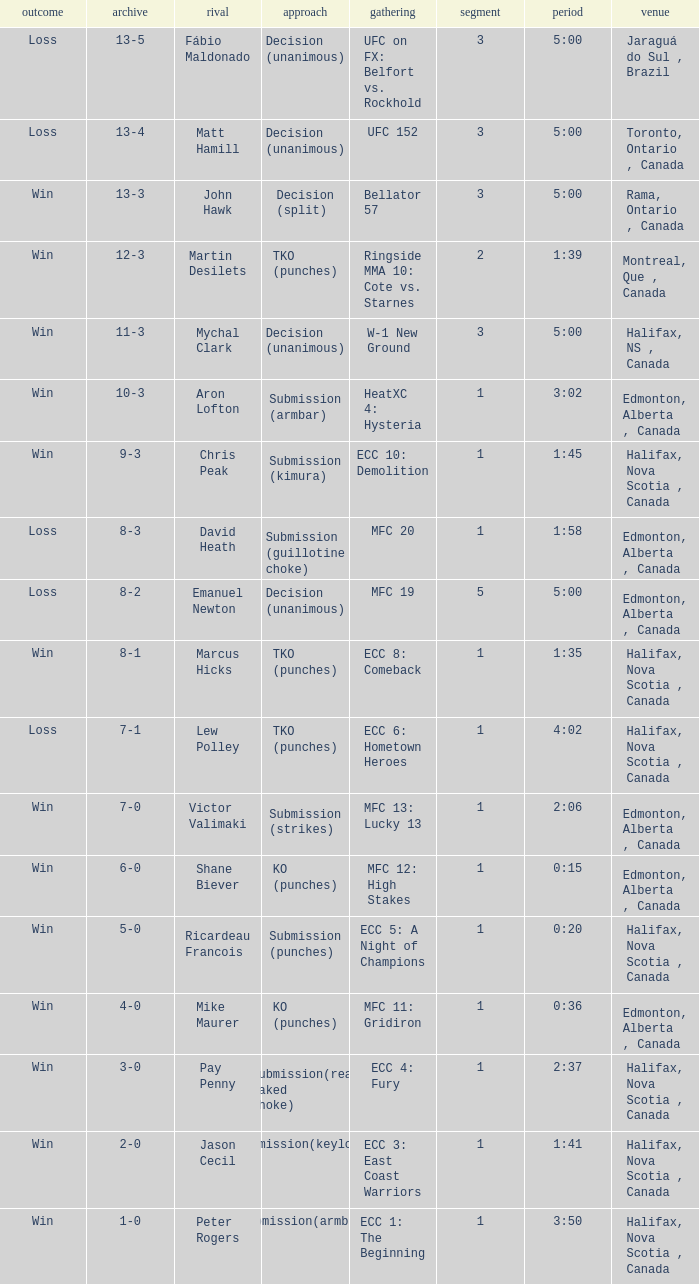Give me the full table as a dictionary. {'header': ['outcome', 'archive', 'rival', 'approach', 'gathering', 'segment', 'period', 'venue'], 'rows': [['Loss', '13-5', 'Fábio Maldonado', 'Decision (unanimous)', 'UFC on FX: Belfort vs. Rockhold', '3', '5:00', 'Jaraguá do Sul , Brazil'], ['Loss', '13-4', 'Matt Hamill', 'Decision (unanimous)', 'UFC 152', '3', '5:00', 'Toronto, Ontario , Canada'], ['Win', '13-3', 'John Hawk', 'Decision (split)', 'Bellator 57', '3', '5:00', 'Rama, Ontario , Canada'], ['Win', '12-3', 'Martin Desilets', 'TKO (punches)', 'Ringside MMA 10: Cote vs. Starnes', '2', '1:39', 'Montreal, Que , Canada'], ['Win', '11-3', 'Mychal Clark', 'Decision (unanimous)', 'W-1 New Ground', '3', '5:00', 'Halifax, NS , Canada'], ['Win', '10-3', 'Aron Lofton', 'Submission (armbar)', 'HeatXC 4: Hysteria', '1', '3:02', 'Edmonton, Alberta , Canada'], ['Win', '9-3', 'Chris Peak', 'Submission (kimura)', 'ECC 10: Demolition', '1', '1:45', 'Halifax, Nova Scotia , Canada'], ['Loss', '8-3', 'David Heath', 'Submission (guillotine choke)', 'MFC 20', '1', '1:58', 'Edmonton, Alberta , Canada'], ['Loss', '8-2', 'Emanuel Newton', 'Decision (unanimous)', 'MFC 19', '5', '5:00', 'Edmonton, Alberta , Canada'], ['Win', '8-1', 'Marcus Hicks', 'TKO (punches)', 'ECC 8: Comeback', '1', '1:35', 'Halifax, Nova Scotia , Canada'], ['Loss', '7-1', 'Lew Polley', 'TKO (punches)', 'ECC 6: Hometown Heroes', '1', '4:02', 'Halifax, Nova Scotia , Canada'], ['Win', '7-0', 'Victor Valimaki', 'Submission (strikes)', 'MFC 13: Lucky 13', '1', '2:06', 'Edmonton, Alberta , Canada'], ['Win', '6-0', 'Shane Biever', 'KO (punches)', 'MFC 12: High Stakes', '1', '0:15', 'Edmonton, Alberta , Canada'], ['Win', '5-0', 'Ricardeau Francois', 'Submission (punches)', 'ECC 5: A Night of Champions', '1', '0:20', 'Halifax, Nova Scotia , Canada'], ['Win', '4-0', 'Mike Maurer', 'KO (punches)', 'MFC 11: Gridiron', '1', '0:36', 'Edmonton, Alberta , Canada'], ['Win', '3-0', 'Pay Penny', 'Submission(rear naked choke)', 'ECC 4: Fury', '1', '2:37', 'Halifax, Nova Scotia , Canada'], ['Win', '2-0', 'Jason Cecil', 'Submission(keylock)', 'ECC 3: East Coast Warriors', '1', '1:41', 'Halifax, Nova Scotia , Canada'], ['Win', '1-0', 'Peter Rogers', 'Submission(armbar)', 'ECC 1: The Beginning', '1', '3:50', 'Halifax, Nova Scotia , Canada']]} What is the round of the match with Emanuel Newton as the opponent? 5.0. 